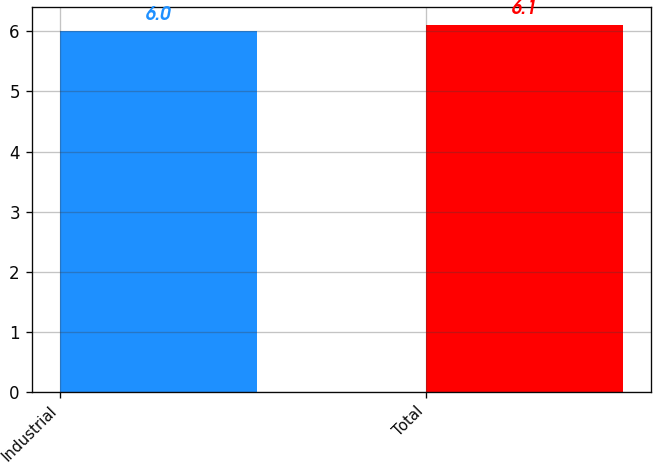Convert chart. <chart><loc_0><loc_0><loc_500><loc_500><bar_chart><fcel>Industrial<fcel>Total<nl><fcel>6<fcel>6.1<nl></chart> 